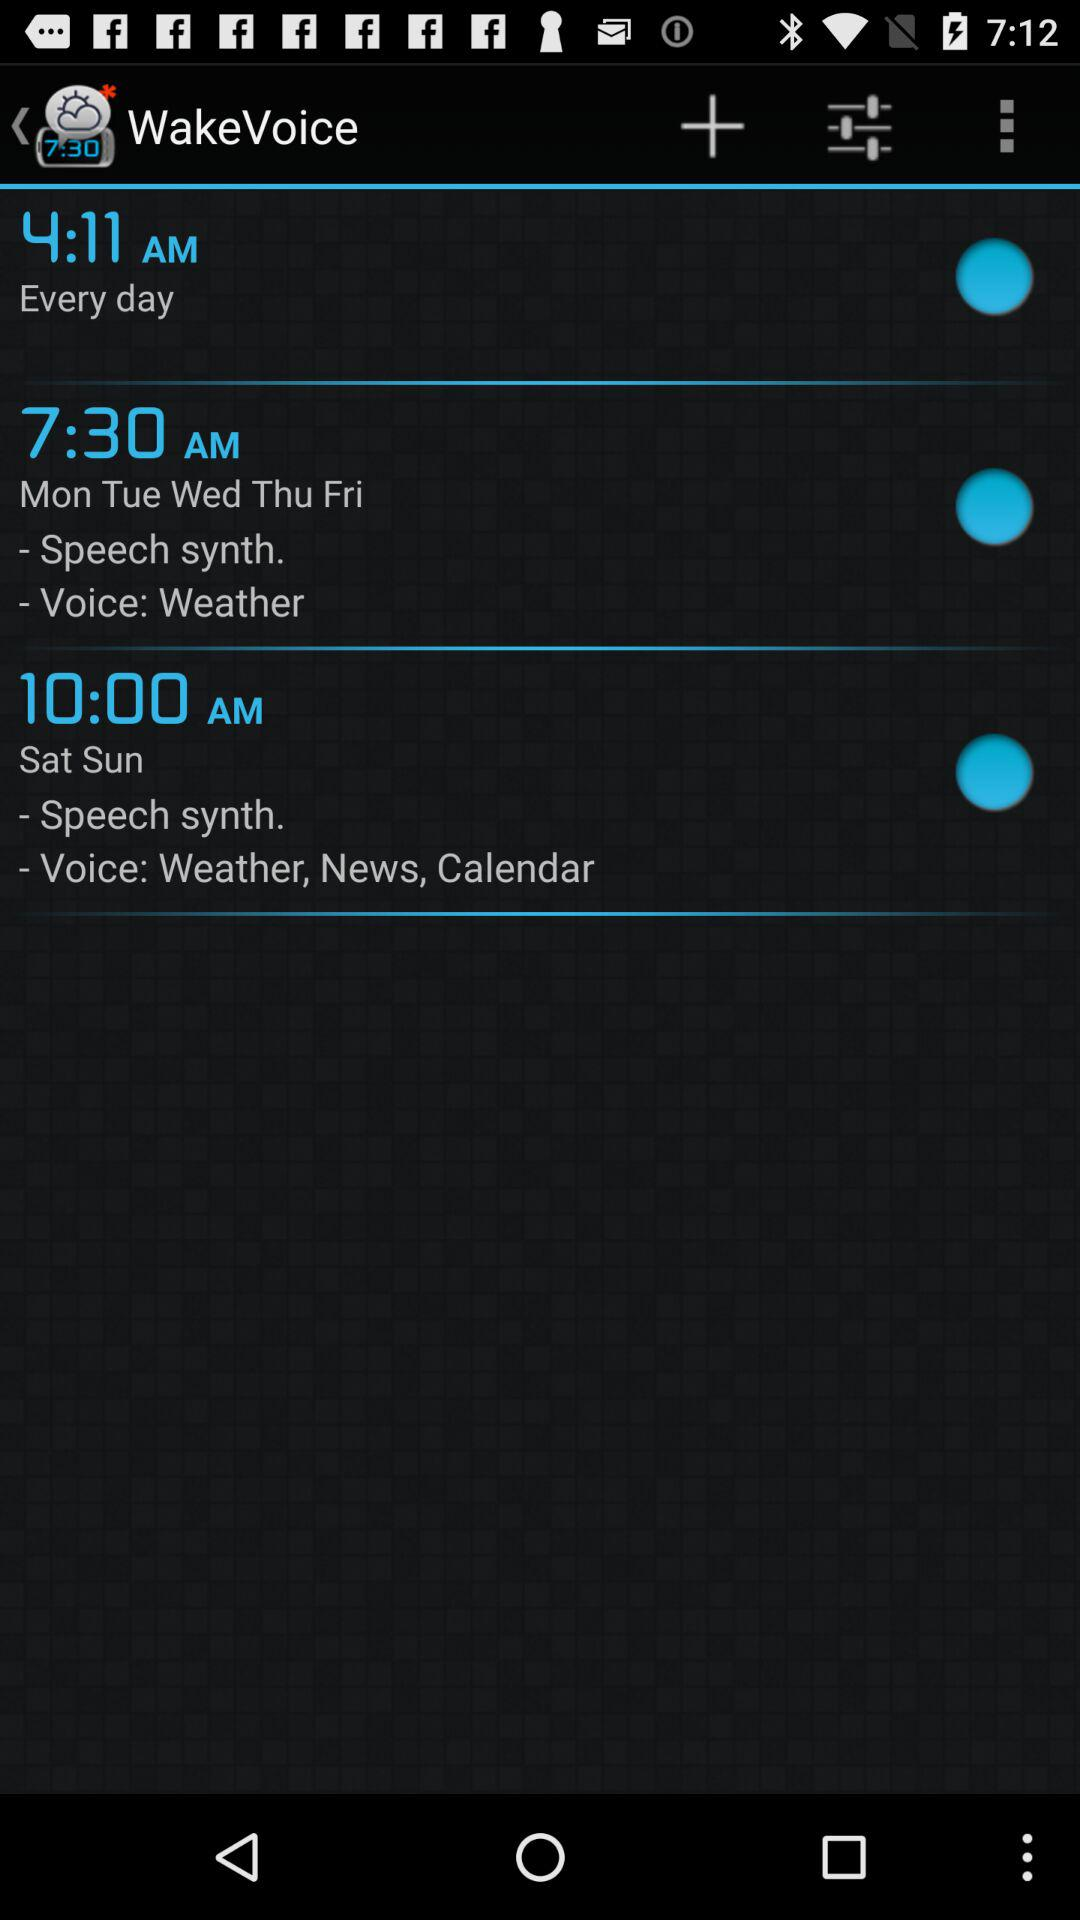Which voice is set for Monday to Friday? The set voice for Monday to Friday is "Weather". 